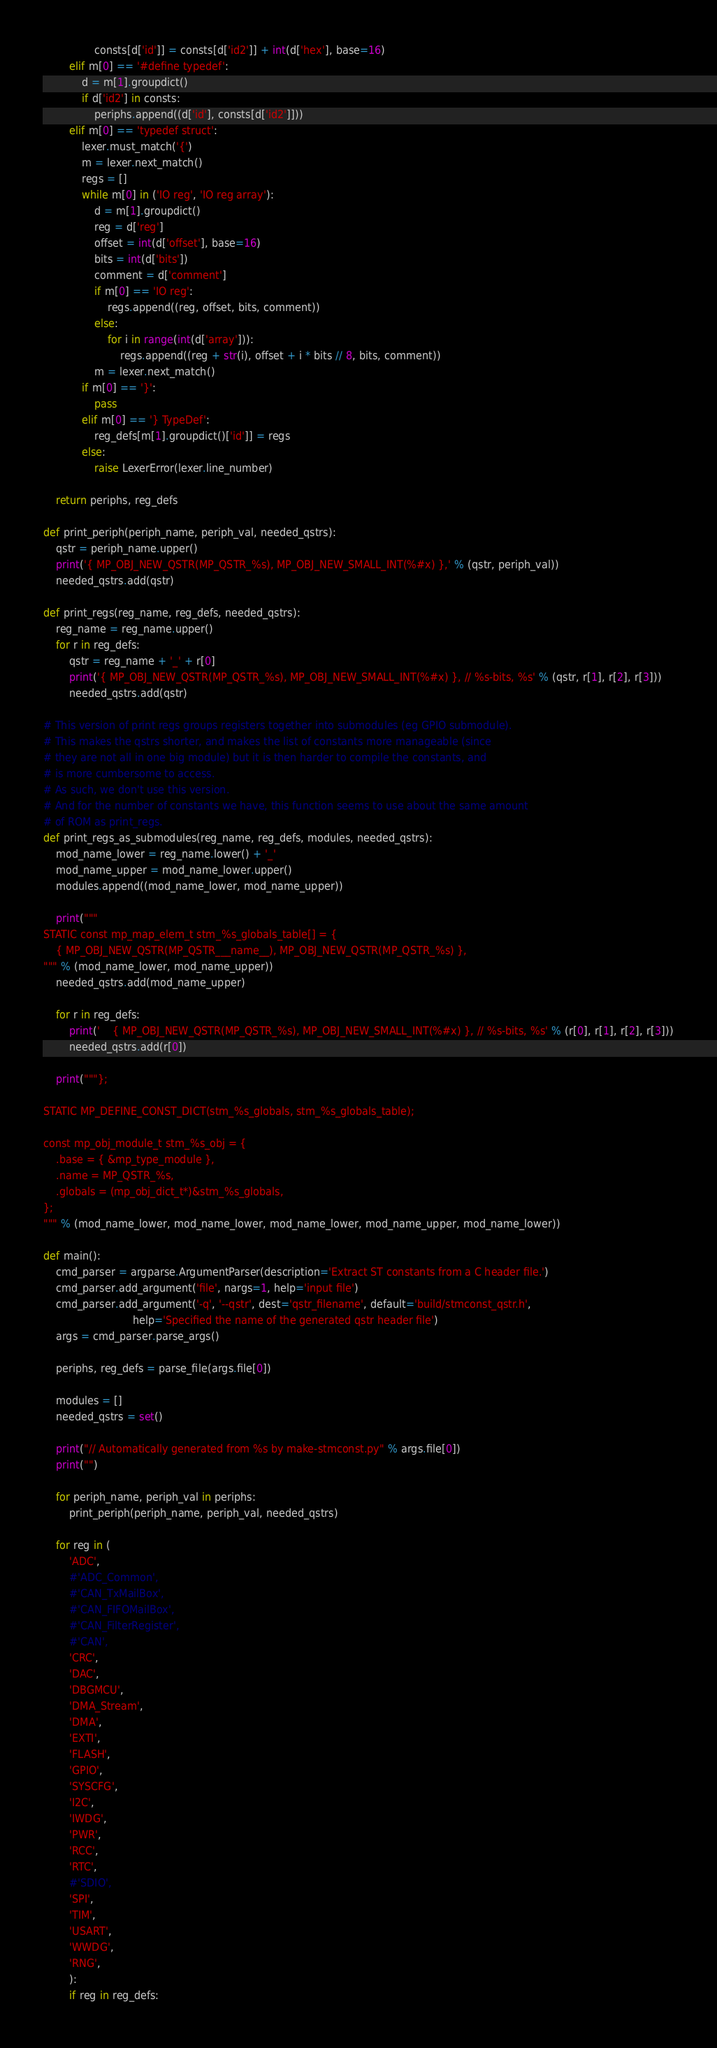Convert code to text. <code><loc_0><loc_0><loc_500><loc_500><_Python_>                consts[d['id']] = consts[d['id2']] + int(d['hex'], base=16)
        elif m[0] == '#define typedef':
            d = m[1].groupdict()
            if d['id2'] in consts:
                periphs.append((d['id'], consts[d['id2']]))
        elif m[0] == 'typedef struct':
            lexer.must_match('{')
            m = lexer.next_match()
            regs = []
            while m[0] in ('IO reg', 'IO reg array'):
                d = m[1].groupdict()
                reg = d['reg']
                offset = int(d['offset'], base=16)
                bits = int(d['bits'])
                comment = d['comment']
                if m[0] == 'IO reg':
                    regs.append((reg, offset, bits, comment))
                else:
                    for i in range(int(d['array'])):
                        regs.append((reg + str(i), offset + i * bits // 8, bits, comment))
                m = lexer.next_match()
            if m[0] == '}':
                pass
            elif m[0] == '} TypeDef':
                reg_defs[m[1].groupdict()['id']] = regs
            else:
                raise LexerError(lexer.line_number)

    return periphs, reg_defs

def print_periph(periph_name, periph_val, needed_qstrs):
    qstr = periph_name.upper()
    print('{ MP_OBJ_NEW_QSTR(MP_QSTR_%s), MP_OBJ_NEW_SMALL_INT(%#x) },' % (qstr, periph_val))
    needed_qstrs.add(qstr)

def print_regs(reg_name, reg_defs, needed_qstrs):
    reg_name = reg_name.upper()
    for r in reg_defs:
        qstr = reg_name + '_' + r[0]
        print('{ MP_OBJ_NEW_QSTR(MP_QSTR_%s), MP_OBJ_NEW_SMALL_INT(%#x) }, // %s-bits, %s' % (qstr, r[1], r[2], r[3]))
        needed_qstrs.add(qstr)

# This version of print regs groups registers together into submodules (eg GPIO submodule).
# This makes the qstrs shorter, and makes the list of constants more manageable (since
# they are not all in one big module) but it is then harder to compile the constants, and
# is more cumbersome to access.
# As such, we don't use this version.
# And for the number of constants we have, this function seems to use about the same amount
# of ROM as print_regs.
def print_regs_as_submodules(reg_name, reg_defs, modules, needed_qstrs):
    mod_name_lower = reg_name.lower() + '_'
    mod_name_upper = mod_name_lower.upper()
    modules.append((mod_name_lower, mod_name_upper))

    print("""
STATIC const mp_map_elem_t stm_%s_globals_table[] = {
    { MP_OBJ_NEW_QSTR(MP_QSTR___name__), MP_OBJ_NEW_QSTR(MP_QSTR_%s) },
""" % (mod_name_lower, mod_name_upper))
    needed_qstrs.add(mod_name_upper)

    for r in reg_defs:
        print('    { MP_OBJ_NEW_QSTR(MP_QSTR_%s), MP_OBJ_NEW_SMALL_INT(%#x) }, // %s-bits, %s' % (r[0], r[1], r[2], r[3]))
        needed_qstrs.add(r[0])

    print("""};

STATIC MP_DEFINE_CONST_DICT(stm_%s_globals, stm_%s_globals_table);

const mp_obj_module_t stm_%s_obj = {
    .base = { &mp_type_module },
    .name = MP_QSTR_%s,
    .globals = (mp_obj_dict_t*)&stm_%s_globals,
};
""" % (mod_name_lower, mod_name_lower, mod_name_lower, mod_name_upper, mod_name_lower))

def main():
    cmd_parser = argparse.ArgumentParser(description='Extract ST constants from a C header file.')
    cmd_parser.add_argument('file', nargs=1, help='input file')
    cmd_parser.add_argument('-q', '--qstr', dest='qstr_filename', default='build/stmconst_qstr.h',
                            help='Specified the name of the generated qstr header file')
    args = cmd_parser.parse_args()

    periphs, reg_defs = parse_file(args.file[0])

    modules = []
    needed_qstrs = set()

    print("// Automatically generated from %s by make-stmconst.py" % args.file[0])
    print("")

    for periph_name, periph_val in periphs:
        print_periph(periph_name, periph_val, needed_qstrs)

    for reg in (
        'ADC',
        #'ADC_Common',
        #'CAN_TxMailBox',
        #'CAN_FIFOMailBox',
        #'CAN_FilterRegister',
        #'CAN',
        'CRC',
        'DAC',
        'DBGMCU',
        'DMA_Stream',
        'DMA',
        'EXTI',
        'FLASH',
        'GPIO',
        'SYSCFG',
        'I2C',
        'IWDG',
        'PWR',
        'RCC',
        'RTC',
        #'SDIO',
        'SPI',
        'TIM',
        'USART',
        'WWDG',
        'RNG',
        ):
        if reg in reg_defs:</code> 